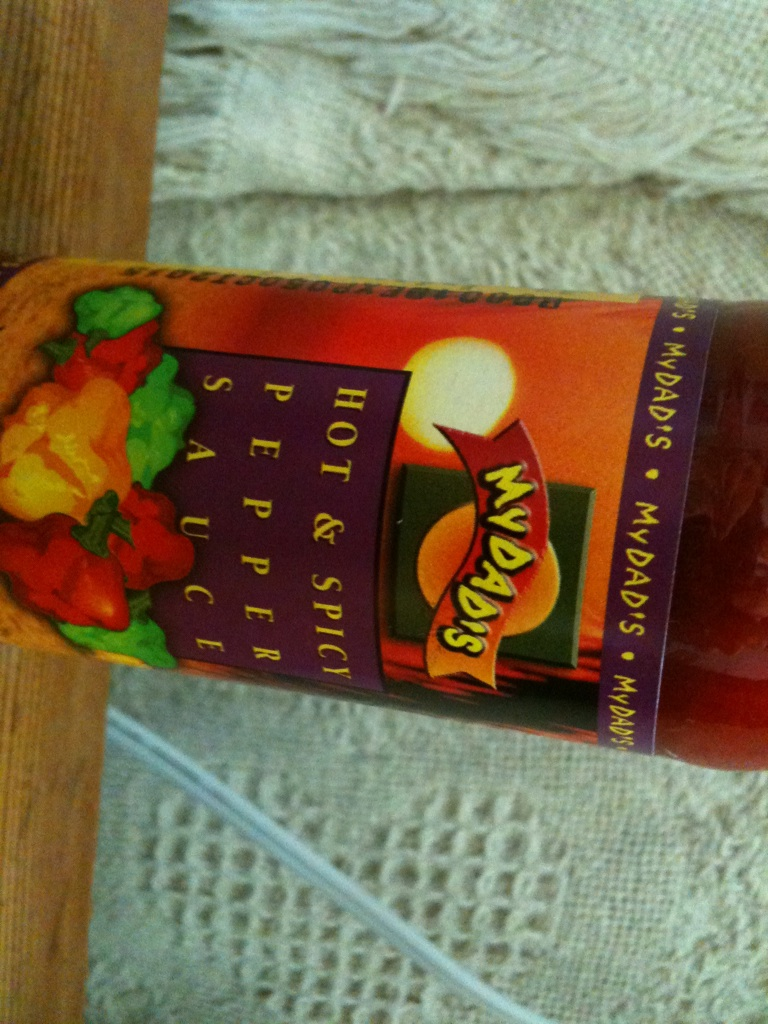What flavors are commonly paired with this type of pepper sauce? Pepper sauce is often paired with a variety of flavors. It goes well with grilled meats, seafood, and vegetables. It can also enhance the flavor of soups, stews, tacos, and even some pasta dishes. The heat from the pepper sauce complements tangy, savory, and sometimes even slightly sweet flavors. 